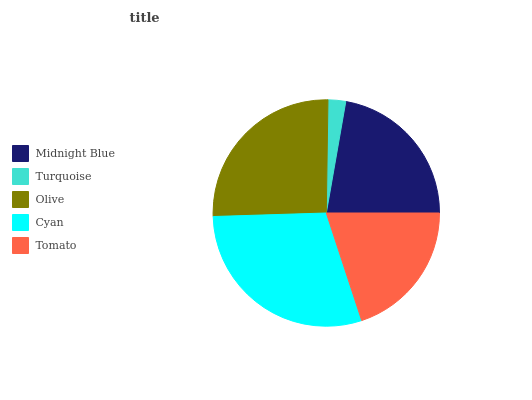Is Turquoise the minimum?
Answer yes or no. Yes. Is Cyan the maximum?
Answer yes or no. Yes. Is Olive the minimum?
Answer yes or no. No. Is Olive the maximum?
Answer yes or no. No. Is Olive greater than Turquoise?
Answer yes or no. Yes. Is Turquoise less than Olive?
Answer yes or no. Yes. Is Turquoise greater than Olive?
Answer yes or no. No. Is Olive less than Turquoise?
Answer yes or no. No. Is Midnight Blue the high median?
Answer yes or no. Yes. Is Midnight Blue the low median?
Answer yes or no. Yes. Is Tomato the high median?
Answer yes or no. No. Is Cyan the low median?
Answer yes or no. No. 